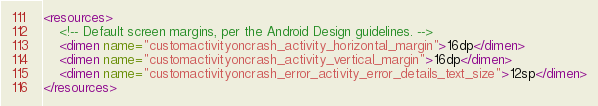Convert code to text. <code><loc_0><loc_0><loc_500><loc_500><_XML_><resources>
    <!-- Default screen margins, per the Android Design guidelines. -->
    <dimen name="customactivityoncrash_activity_horizontal_margin">16dp</dimen>
    <dimen name="customactivityoncrash_activity_vertical_margin">16dp</dimen>
    <dimen name="customactivityoncrash_error_activity_error_details_text_size">12sp</dimen>
</resources>
</code> 